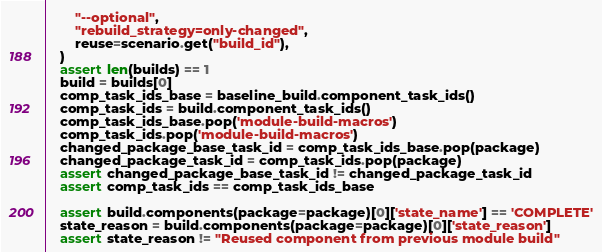<code> <loc_0><loc_0><loc_500><loc_500><_Python_>        "--optional",
        "rebuild_strategy=only-changed",
        reuse=scenario.get("build_id"),
    )
    assert len(builds) == 1
    build = builds[0]
    comp_task_ids_base = baseline_build.component_task_ids()
    comp_task_ids = build.component_task_ids()
    comp_task_ids_base.pop('module-build-macros')
    comp_task_ids.pop('module-build-macros')
    changed_package_base_task_id = comp_task_ids_base.pop(package)
    changed_package_task_id = comp_task_ids.pop(package)
    assert changed_package_base_task_id != changed_package_task_id
    assert comp_task_ids == comp_task_ids_base

    assert build.components(package=package)[0]['state_name'] == 'COMPLETE'
    state_reason = build.components(package=package)[0]['state_reason']
    assert state_reason != "Reused component from previous module build"
</code> 